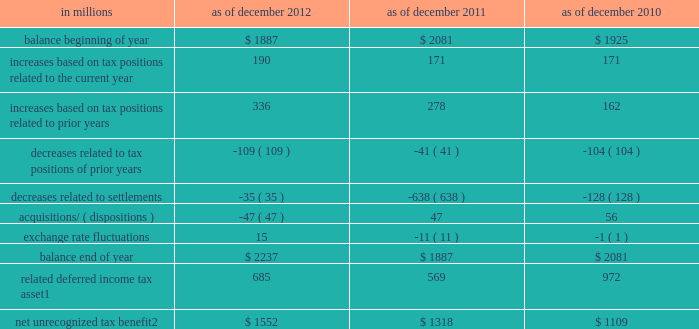Notes to consolidated financial statements the firm permanently reinvests eligible earnings of certain foreign subsidiaries and , accordingly , does not accrue any u.s .
Income taxes that would arise if such earnings were repatriated .
As of december 2012 and december 2011 , this policy resulted in an unrecognized net deferred tax liability of $ 3.75 billion and $ 3.32 billion , respectively , attributable to reinvested earnings of $ 21.69 billion and $ 20.63 billion , respectively .
Unrecognized tax benefits the firm recognizes tax positions in the financial statements only when it is more likely than not that the position will be sustained on examination by the relevant taxing authority based on the technical merits of the position .
A position that meets this standard is measured at the largest amount of benefit that will more likely than not be realized on settlement .
A liability is established for differences between positions taken in a tax return and amounts recognized in the financial statements .
As of december 2012 and december 2011 , the accrued liability for interest expense related to income tax matters and income tax penalties was $ 374 million and $ 233 million , respectively .
The firm recognized $ 95 million , $ 21 million and $ 28 million of interest and income tax penalties for the years ended december 2012 , december 2011 and december 2010 , respectively .
It is reasonably possible that unrecognized tax benefits could change significantly during the twelve months subsequent to december 2012 due to potential audit settlements , however , at this time it is not possible to estimate any potential change .
The table below presents the changes in the liability for unrecognized tax benefits .
This liability is included in 201cother liabilities and accrued expenses . 201d see note 17 for further information. .
Related deferred income tax asset 1 685 569 972 net unrecognized tax benefit 2 $ 1552 $ 1318 $ 1109 1 .
Included in 201cother assets . 201d see note 12 .
If recognized , the net tax benefit would reduce the firm 2019s effective income tax rate .
194 goldman sachs 2012 annual report .
What is the percentage change in the net unrecognized tax benefit in 2011 compare to 2010? 
Computations: ((1318 - 1109) / 1109)
Answer: 0.18846. 